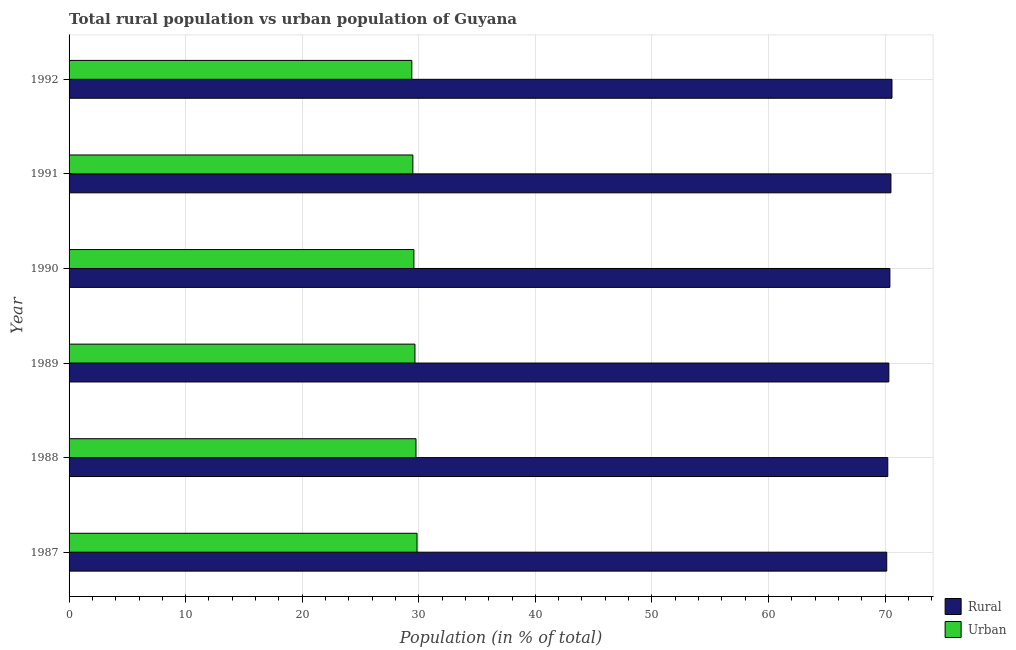How many groups of bars are there?
Offer a very short reply. 6. How many bars are there on the 5th tick from the bottom?
Offer a terse response. 2. What is the label of the 3rd group of bars from the top?
Your response must be concise. 1990. What is the urban population in 1992?
Your answer should be compact. 29.4. Across all years, what is the maximum rural population?
Give a very brief answer. 70.6. Across all years, what is the minimum urban population?
Your answer should be very brief. 29.4. In which year was the urban population maximum?
Your answer should be very brief. 1987. In which year was the rural population minimum?
Your response must be concise. 1987. What is the total urban population in the graph?
Your answer should be compact. 177.77. What is the difference between the rural population in 1987 and that in 1991?
Make the answer very short. -0.36. What is the difference between the rural population in 1990 and the urban population in 1988?
Your response must be concise. 40.65. What is the average rural population per year?
Ensure brevity in your answer.  70.37. In the year 1989, what is the difference between the urban population and rural population?
Your response must be concise. -40.65. In how many years, is the rural population greater than 8 %?
Provide a short and direct response. 6. Is the urban population in 1990 less than that in 1991?
Provide a short and direct response. No. Is the difference between the rural population in 1987 and 1991 greater than the difference between the urban population in 1987 and 1991?
Offer a very short reply. No. What is the difference between the highest and the second highest urban population?
Ensure brevity in your answer.  0.09. What is the difference between the highest and the lowest urban population?
Offer a terse response. 0.45. What does the 1st bar from the top in 1992 represents?
Offer a very short reply. Urban. What does the 1st bar from the bottom in 1992 represents?
Make the answer very short. Rural. How many bars are there?
Provide a short and direct response. 12. How many years are there in the graph?
Provide a succinct answer. 6. What is the difference between two consecutive major ticks on the X-axis?
Your response must be concise. 10. Where does the legend appear in the graph?
Offer a very short reply. Bottom right. How are the legend labels stacked?
Your answer should be compact. Vertical. What is the title of the graph?
Your response must be concise. Total rural population vs urban population of Guyana. Does "Urban Population" appear as one of the legend labels in the graph?
Give a very brief answer. No. What is the label or title of the X-axis?
Make the answer very short. Population (in % of total). What is the label or title of the Y-axis?
Make the answer very short. Year. What is the Population (in % of total) in Rural in 1987?
Keep it short and to the point. 70.15. What is the Population (in % of total) in Urban in 1987?
Offer a terse response. 29.85. What is the Population (in % of total) in Rural in 1988?
Your response must be concise. 70.24. What is the Population (in % of total) of Urban in 1988?
Your response must be concise. 29.76. What is the Population (in % of total) in Rural in 1989?
Give a very brief answer. 70.33. What is the Population (in % of total) of Urban in 1989?
Your answer should be very brief. 29.67. What is the Population (in % of total) of Rural in 1990?
Offer a very short reply. 70.42. What is the Population (in % of total) of Urban in 1990?
Ensure brevity in your answer.  29.58. What is the Population (in % of total) in Rural in 1991?
Give a very brief answer. 70.51. What is the Population (in % of total) in Urban in 1991?
Keep it short and to the point. 29.49. What is the Population (in % of total) of Rural in 1992?
Your answer should be compact. 70.6. What is the Population (in % of total) of Urban in 1992?
Ensure brevity in your answer.  29.4. Across all years, what is the maximum Population (in % of total) of Rural?
Your answer should be compact. 70.6. Across all years, what is the maximum Population (in % of total) in Urban?
Provide a succinct answer. 29.85. Across all years, what is the minimum Population (in % of total) in Rural?
Provide a succinct answer. 70.15. Across all years, what is the minimum Population (in % of total) of Urban?
Your answer should be very brief. 29.4. What is the total Population (in % of total) of Rural in the graph?
Offer a terse response. 422.23. What is the total Population (in % of total) of Urban in the graph?
Make the answer very short. 177.77. What is the difference between the Population (in % of total) in Rural in 1987 and that in 1988?
Offer a very short reply. -0.09. What is the difference between the Population (in % of total) in Urban in 1987 and that in 1988?
Keep it short and to the point. 0.09. What is the difference between the Population (in % of total) in Rural in 1987 and that in 1989?
Provide a short and direct response. -0.18. What is the difference between the Population (in % of total) of Urban in 1987 and that in 1989?
Make the answer very short. 0.18. What is the difference between the Population (in % of total) in Rural in 1987 and that in 1990?
Keep it short and to the point. -0.27. What is the difference between the Population (in % of total) in Urban in 1987 and that in 1990?
Your answer should be compact. 0.27. What is the difference between the Population (in % of total) of Rural in 1987 and that in 1991?
Ensure brevity in your answer.  -0.36. What is the difference between the Population (in % of total) of Urban in 1987 and that in 1991?
Your answer should be compact. 0.36. What is the difference between the Population (in % of total) of Rural in 1987 and that in 1992?
Keep it short and to the point. -0.45. What is the difference between the Population (in % of total) of Urban in 1987 and that in 1992?
Provide a succinct answer. 0.45. What is the difference between the Population (in % of total) in Rural in 1988 and that in 1989?
Your answer should be very brief. -0.09. What is the difference between the Population (in % of total) in Urban in 1988 and that in 1989?
Your answer should be very brief. 0.09. What is the difference between the Population (in % of total) of Rural in 1988 and that in 1990?
Keep it short and to the point. -0.18. What is the difference between the Population (in % of total) in Urban in 1988 and that in 1990?
Offer a very short reply. 0.18. What is the difference between the Population (in % of total) of Rural in 1988 and that in 1991?
Your answer should be very brief. -0.27. What is the difference between the Population (in % of total) in Urban in 1988 and that in 1991?
Your answer should be compact. 0.27. What is the difference between the Population (in % of total) in Rural in 1988 and that in 1992?
Provide a short and direct response. -0.36. What is the difference between the Population (in % of total) of Urban in 1988 and that in 1992?
Give a very brief answer. 0.36. What is the difference between the Population (in % of total) of Rural in 1989 and that in 1990?
Provide a succinct answer. -0.09. What is the difference between the Population (in % of total) in Urban in 1989 and that in 1990?
Provide a succinct answer. 0.09. What is the difference between the Population (in % of total) of Rural in 1989 and that in 1991?
Give a very brief answer. -0.18. What is the difference between the Population (in % of total) of Urban in 1989 and that in 1991?
Your answer should be very brief. 0.18. What is the difference between the Population (in % of total) of Rural in 1989 and that in 1992?
Your answer should be compact. -0.27. What is the difference between the Population (in % of total) of Urban in 1989 and that in 1992?
Offer a terse response. 0.27. What is the difference between the Population (in % of total) of Rural in 1990 and that in 1991?
Make the answer very short. -0.09. What is the difference between the Population (in % of total) of Urban in 1990 and that in 1991?
Your answer should be very brief. 0.09. What is the difference between the Population (in % of total) in Rural in 1990 and that in 1992?
Your response must be concise. -0.18. What is the difference between the Population (in % of total) in Urban in 1990 and that in 1992?
Offer a terse response. 0.18. What is the difference between the Population (in % of total) of Rural in 1991 and that in 1992?
Offer a very short reply. -0.09. What is the difference between the Population (in % of total) in Urban in 1991 and that in 1992?
Offer a very short reply. 0.09. What is the difference between the Population (in % of total) in Rural in 1987 and the Population (in % of total) in Urban in 1988?
Your answer should be very brief. 40.38. What is the difference between the Population (in % of total) in Rural in 1987 and the Population (in % of total) in Urban in 1989?
Provide a succinct answer. 40.47. What is the difference between the Population (in % of total) in Rural in 1987 and the Population (in % of total) in Urban in 1990?
Provide a succinct answer. 40.56. What is the difference between the Population (in % of total) of Rural in 1987 and the Population (in % of total) of Urban in 1991?
Offer a terse response. 40.65. What is the difference between the Population (in % of total) in Rural in 1987 and the Population (in % of total) in Urban in 1992?
Provide a short and direct response. 40.74. What is the difference between the Population (in % of total) of Rural in 1988 and the Population (in % of total) of Urban in 1989?
Your response must be concise. 40.56. What is the difference between the Population (in % of total) of Rural in 1988 and the Population (in % of total) of Urban in 1990?
Offer a very short reply. 40.65. What is the difference between the Population (in % of total) in Rural in 1988 and the Population (in % of total) in Urban in 1991?
Your answer should be very brief. 40.74. What is the difference between the Population (in % of total) of Rural in 1988 and the Population (in % of total) of Urban in 1992?
Your answer should be very brief. 40.83. What is the difference between the Population (in % of total) of Rural in 1989 and the Population (in % of total) of Urban in 1990?
Provide a short and direct response. 40.74. What is the difference between the Population (in % of total) of Rural in 1989 and the Population (in % of total) of Urban in 1991?
Your response must be concise. 40.83. What is the difference between the Population (in % of total) of Rural in 1989 and the Population (in % of total) of Urban in 1992?
Your answer should be compact. 40.92. What is the difference between the Population (in % of total) in Rural in 1990 and the Population (in % of total) in Urban in 1991?
Your answer should be very brief. 40.92. What is the difference between the Population (in % of total) of Rural in 1990 and the Population (in % of total) of Urban in 1992?
Provide a short and direct response. 41.01. What is the difference between the Population (in % of total) of Rural in 1991 and the Population (in % of total) of Urban in 1992?
Ensure brevity in your answer.  41.1. What is the average Population (in % of total) of Rural per year?
Offer a very short reply. 70.37. What is the average Population (in % of total) of Urban per year?
Ensure brevity in your answer.  29.63. In the year 1987, what is the difference between the Population (in % of total) in Rural and Population (in % of total) in Urban?
Give a very brief answer. 40.29. In the year 1988, what is the difference between the Population (in % of total) of Rural and Population (in % of total) of Urban?
Make the answer very short. 40.47. In the year 1989, what is the difference between the Population (in % of total) of Rural and Population (in % of total) of Urban?
Provide a succinct answer. 40.65. In the year 1990, what is the difference between the Population (in % of total) of Rural and Population (in % of total) of Urban?
Give a very brief answer. 40.83. In the year 1991, what is the difference between the Population (in % of total) of Rural and Population (in % of total) of Urban?
Keep it short and to the point. 41.01. In the year 1992, what is the difference between the Population (in % of total) in Rural and Population (in % of total) in Urban?
Offer a terse response. 41.19. What is the ratio of the Population (in % of total) in Urban in 1987 to that in 1990?
Make the answer very short. 1.01. What is the ratio of the Population (in % of total) of Urban in 1987 to that in 1991?
Your answer should be compact. 1.01. What is the ratio of the Population (in % of total) of Rural in 1987 to that in 1992?
Make the answer very short. 0.99. What is the ratio of the Population (in % of total) of Urban in 1987 to that in 1992?
Give a very brief answer. 1.02. What is the ratio of the Population (in % of total) in Rural in 1988 to that in 1989?
Provide a succinct answer. 1. What is the ratio of the Population (in % of total) in Urban in 1988 to that in 1989?
Provide a short and direct response. 1. What is the ratio of the Population (in % of total) in Rural in 1988 to that in 1990?
Make the answer very short. 1. What is the ratio of the Population (in % of total) of Urban in 1988 to that in 1991?
Your answer should be very brief. 1.01. What is the ratio of the Population (in % of total) of Rural in 1988 to that in 1992?
Offer a very short reply. 0.99. What is the ratio of the Population (in % of total) in Urban in 1988 to that in 1992?
Make the answer very short. 1.01. What is the ratio of the Population (in % of total) of Urban in 1989 to that in 1990?
Your answer should be compact. 1. What is the ratio of the Population (in % of total) in Rural in 1989 to that in 1991?
Give a very brief answer. 1. What is the ratio of the Population (in % of total) of Urban in 1989 to that in 1991?
Give a very brief answer. 1.01. What is the ratio of the Population (in % of total) of Urban in 1989 to that in 1992?
Give a very brief answer. 1.01. What is the ratio of the Population (in % of total) of Rural in 1990 to that in 1991?
Offer a very short reply. 1. What is the ratio of the Population (in % of total) in Rural in 1991 to that in 1992?
Give a very brief answer. 1. What is the ratio of the Population (in % of total) in Urban in 1991 to that in 1992?
Ensure brevity in your answer.  1. What is the difference between the highest and the second highest Population (in % of total) in Rural?
Ensure brevity in your answer.  0.09. What is the difference between the highest and the second highest Population (in % of total) in Urban?
Give a very brief answer. 0.09. What is the difference between the highest and the lowest Population (in % of total) in Rural?
Your answer should be compact. 0.45. What is the difference between the highest and the lowest Population (in % of total) of Urban?
Provide a succinct answer. 0.45. 